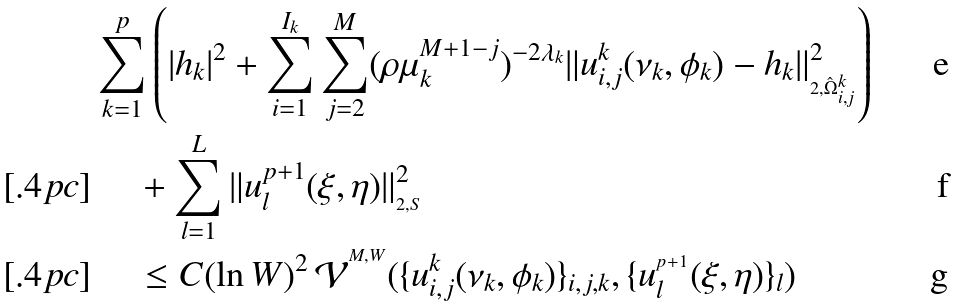<formula> <loc_0><loc_0><loc_500><loc_500>& \sum _ { k = 1 } ^ { p } \left ( \left | h _ { k } \right | ^ { 2 } + \sum _ { i = 1 } ^ { I _ { k } } \sum _ { j = 2 } ^ { M } ( \rho \mu _ { k } ^ { M + 1 - j } ) ^ { - 2 \lambda _ { k } } \| u _ { i , j } ^ { k } ( \nu _ { k } , \phi _ { k } ) - h _ { k } \| _ { _ { 2 , \hat { \Omega } _ { i , j } ^ { k } } } ^ { 2 } \right ) \\ [ . 4 p c ] & \quad \, + \sum _ { l = 1 } ^ { L } \| u _ { l } ^ { p + 1 } ( \xi , \eta ) \| _ { _ { 2 , S } } ^ { 2 } \\ [ . 4 p c ] & \quad \, \leq C ( \ln W ) ^ { 2 } \, \mathcal { V } ^ { ^ { M , W } } ( \{ u _ { i , j } ^ { k } ( \nu _ { k } , \phi _ { k } ) \} _ { i , j , k } , \{ u _ { l } ^ { _ { ^ { p + 1 } } } ( \xi , \eta ) \} _ { l } )</formula> 